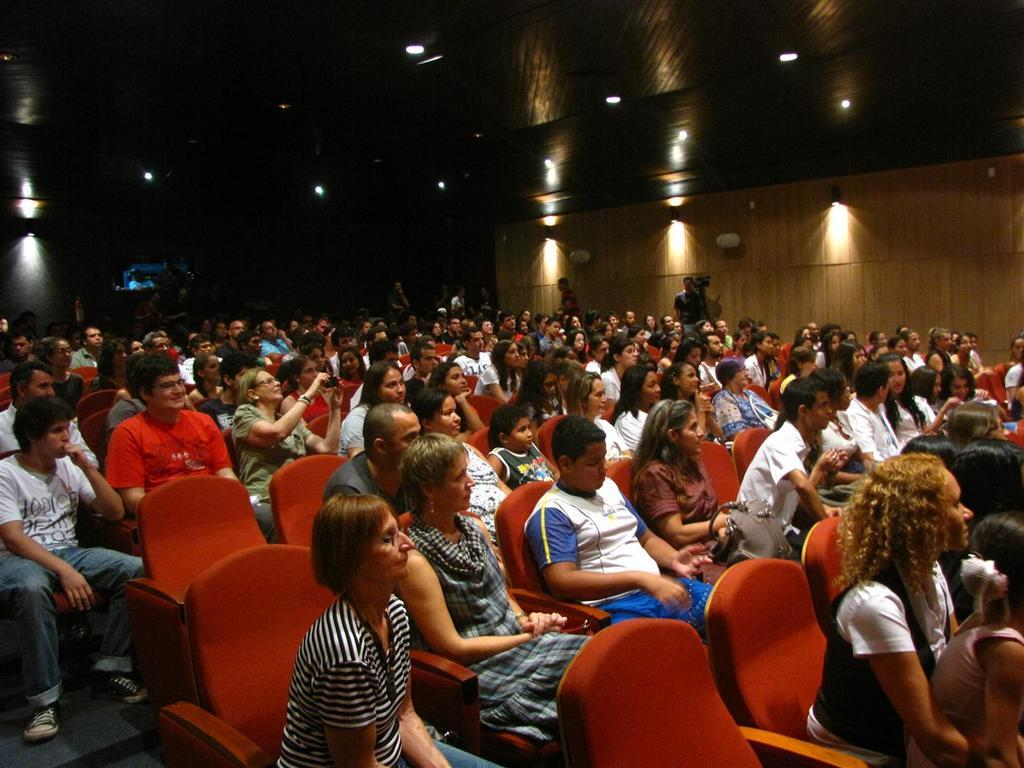What is happening in the image? There is an audience in the image, and they are watching an event. Where is the event taking place? The event is taking place in an auditorium. Can you describe the audience in the image? The audience is seated and focused on the event. What type of wound can be seen on the cub in the image? There is no cub or wound present in the image. What color is the van parked outside the auditorium in the image? There is no van present in the image; it only shows the audience and the event in the auditorium. 